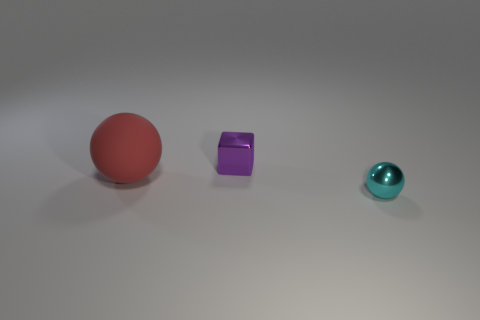Add 1 large red metallic blocks. How many objects exist? 4 Subtract all cubes. How many objects are left? 2 Subtract 0 blue cubes. How many objects are left? 3 Subtract all cyan matte balls. Subtract all big rubber objects. How many objects are left? 2 Add 1 tiny purple metal blocks. How many tiny purple metal blocks are left? 2 Add 3 large red things. How many large red things exist? 4 